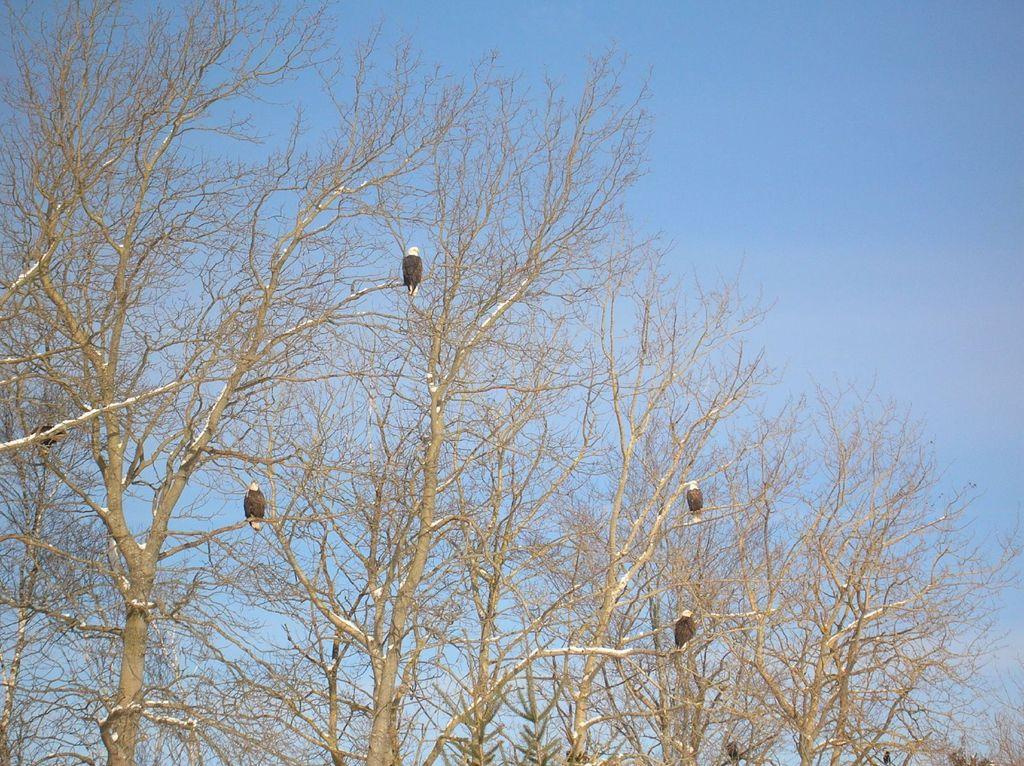What animals are on a tree branch in the image? There are birds on a tree branch in the image. What can be seen in the background of the image? The sky is visible in the background of the image. What is the color of the sky in the image? The color of the sky is blue. What type of juice is being served to the passengers in the image? There are no passengers or juice present in the image; it features birds on a tree branch and a blue sky. 